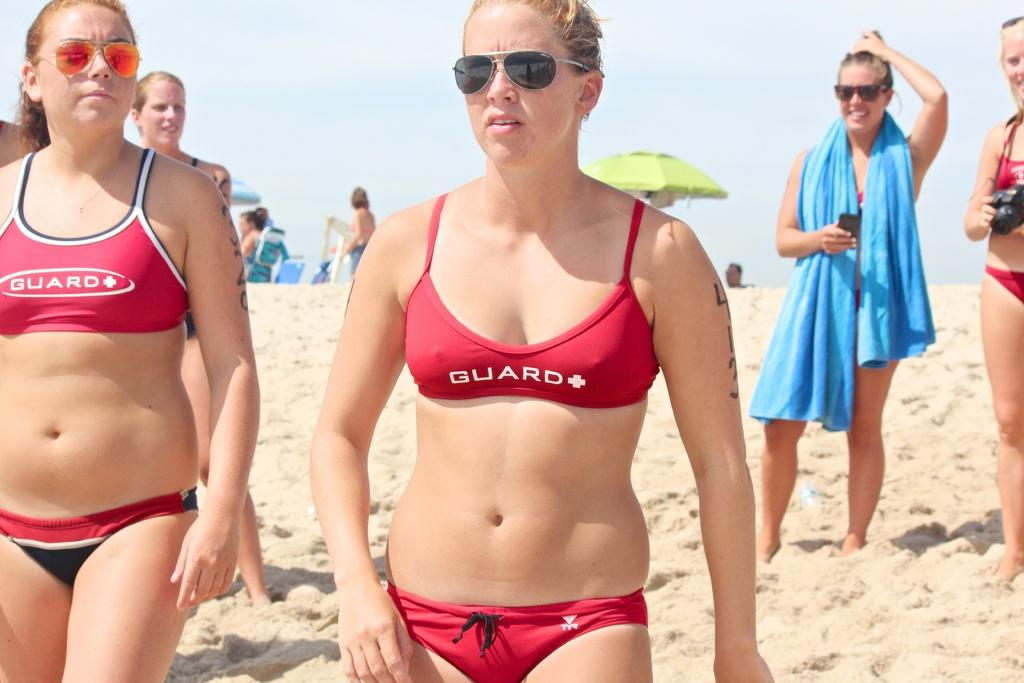Provide a one-sentence caption for the provided image. Two women at a beach wearing red GUARD bikinis. 